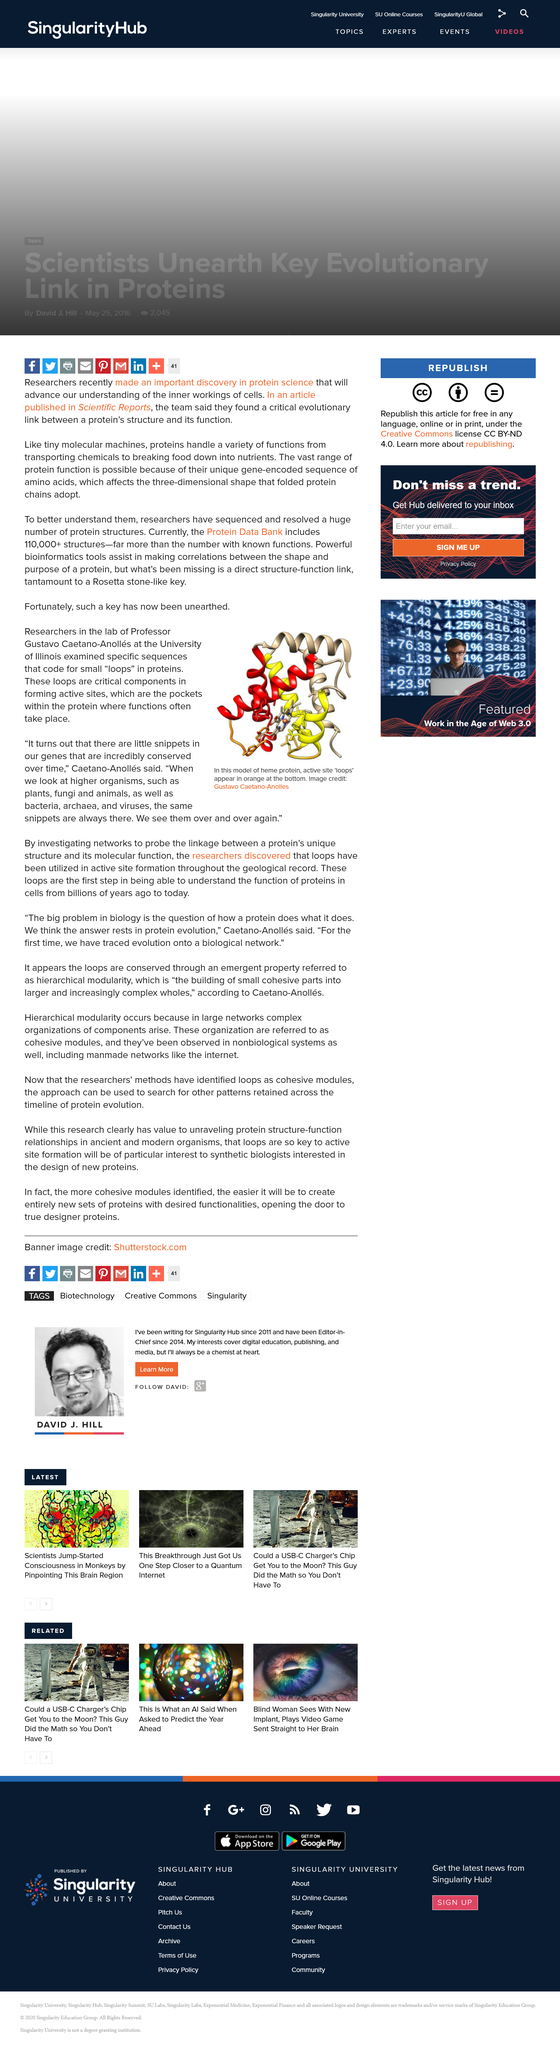Point out several critical features in this image. The loops are crucial for understanding the function of proteins in cells throughout history, from ancient times to the present. Professor Gustavo Caetano-Anolles is affiliated with the University of Illinois. The researchers discovered that loops have been utilized in active site formation throughout the geological record. 